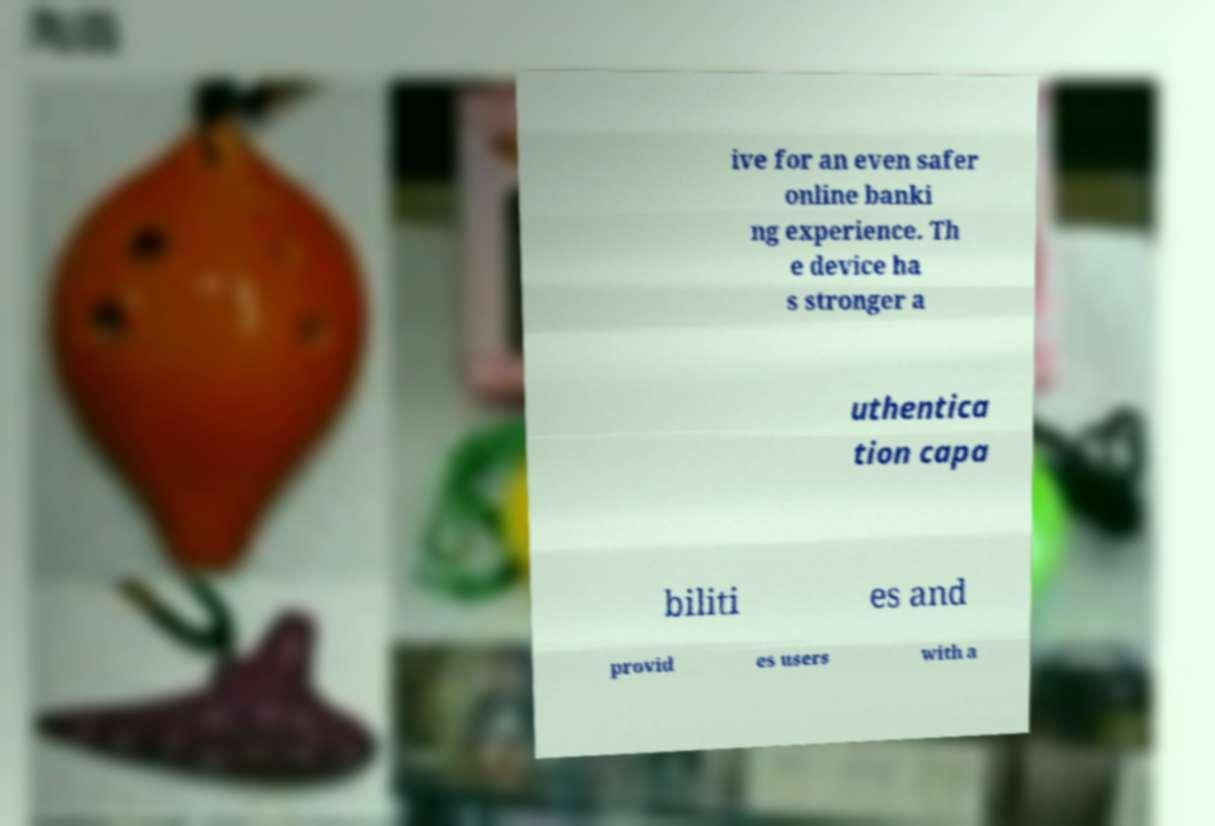What messages or text are displayed in this image? I need them in a readable, typed format. ive for an even safer online banki ng experience. Th e device ha s stronger a uthentica tion capa biliti es and provid es users with a 